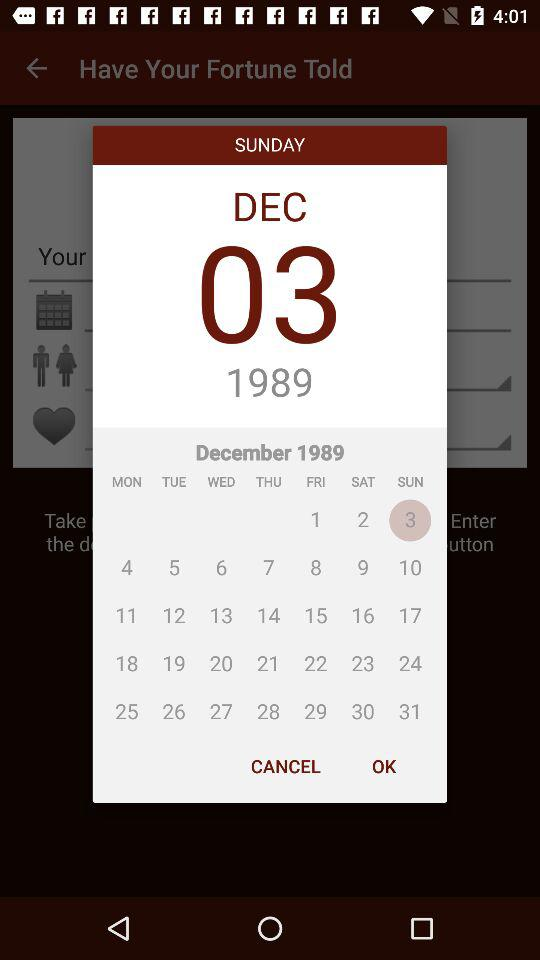What is the selected date? The selected date is Sunday, December 3, 1989. 